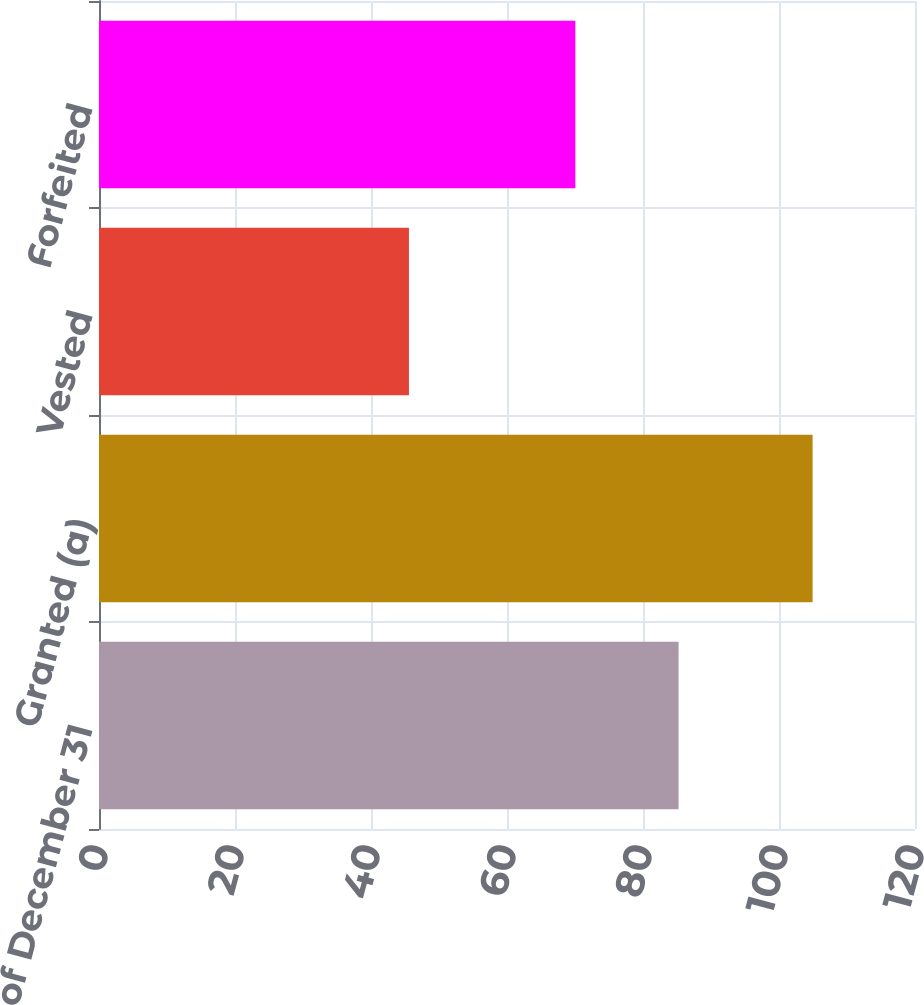Convert chart to OTSL. <chart><loc_0><loc_0><loc_500><loc_500><bar_chart><fcel>Nonvested as of December 31<fcel>Granted (a)<fcel>Vested<fcel>Forfeited<nl><fcel>85.23<fcel>104.94<fcel>45.58<fcel>70.05<nl></chart> 